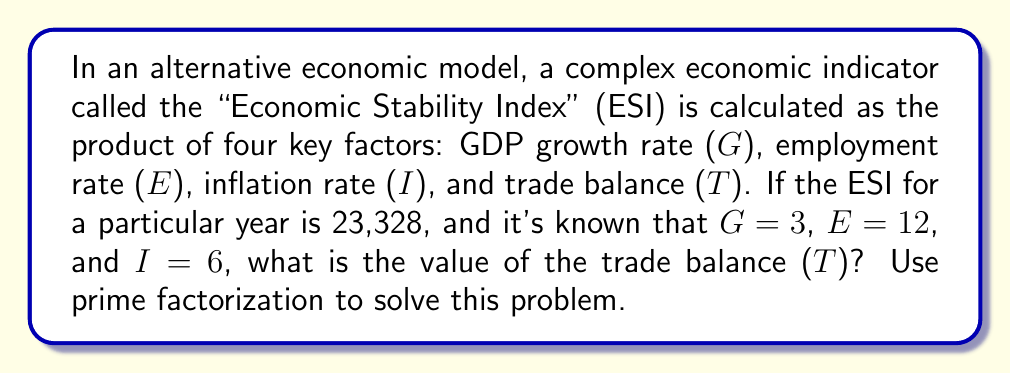Could you help me with this problem? To solve this problem using prime factorization, we'll follow these steps:

1) First, let's express the given information mathematically:

   $ESI = G \times E \times I \times T = 23,328$
   $G = 3$, $E = 12$, $I = 6$, and $T$ is unknown

2) We know that $3 \times 12 \times 6 \times T = 23,328$

3) Let's simplify the left side:
   $216T = 23,328$

4) Now, let's use prime factorization on both sides:

   Left side: $216T = 2^3 \times 3^3 \times T$

   Right side: $23,328 = 2^8 \times 3^2 \times 11$

5) Equating these:

   $2^3 \times 3^3 \times T = 2^8 \times 3^2 \times 11$

6) Canceling out common factors:

   $3 \times T = 2^5 \times 11$

7) Simplifying the right side:

   $3T = 32 \times 11 = 352$

8) Solving for T:

   $T = 352 \div 3 = 117.33333...$

Therefore, the trade balance (T) is approximately 117.33.
Answer: $T \approx 117.33$ 